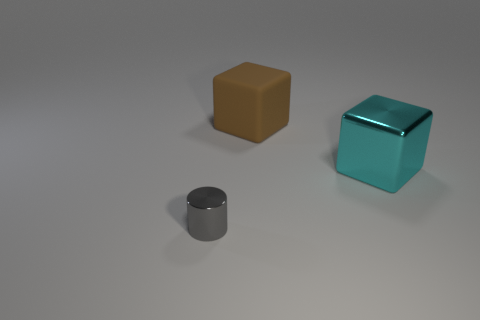What number of small gray shiny things are behind the cylinder in front of the object that is behind the large cyan metal cube?
Your answer should be very brief. 0. What is the object that is right of the large block on the left side of the metal thing that is behind the gray shiny object made of?
Provide a succinct answer. Metal. Are the large block left of the cyan metallic block and the tiny gray object made of the same material?
Your answer should be compact. No. How many cyan metallic cubes are the same size as the cyan metal thing?
Offer a terse response. 0. Is the number of tiny things behind the large matte cube greater than the number of cyan blocks on the left side of the big cyan block?
Your answer should be compact. No. Is there another large matte thing that has the same shape as the big brown object?
Your answer should be very brief. No. How big is the object that is in front of the large cube that is right of the brown block?
Offer a terse response. Small. The thing to the left of the large cube to the left of the metallic thing that is on the right side of the tiny gray metallic cylinder is what shape?
Keep it short and to the point. Cylinder. The cyan block that is made of the same material as the small gray cylinder is what size?
Your answer should be compact. Large. Are there more tiny metallic cylinders than big cyan rubber things?
Provide a succinct answer. Yes. 